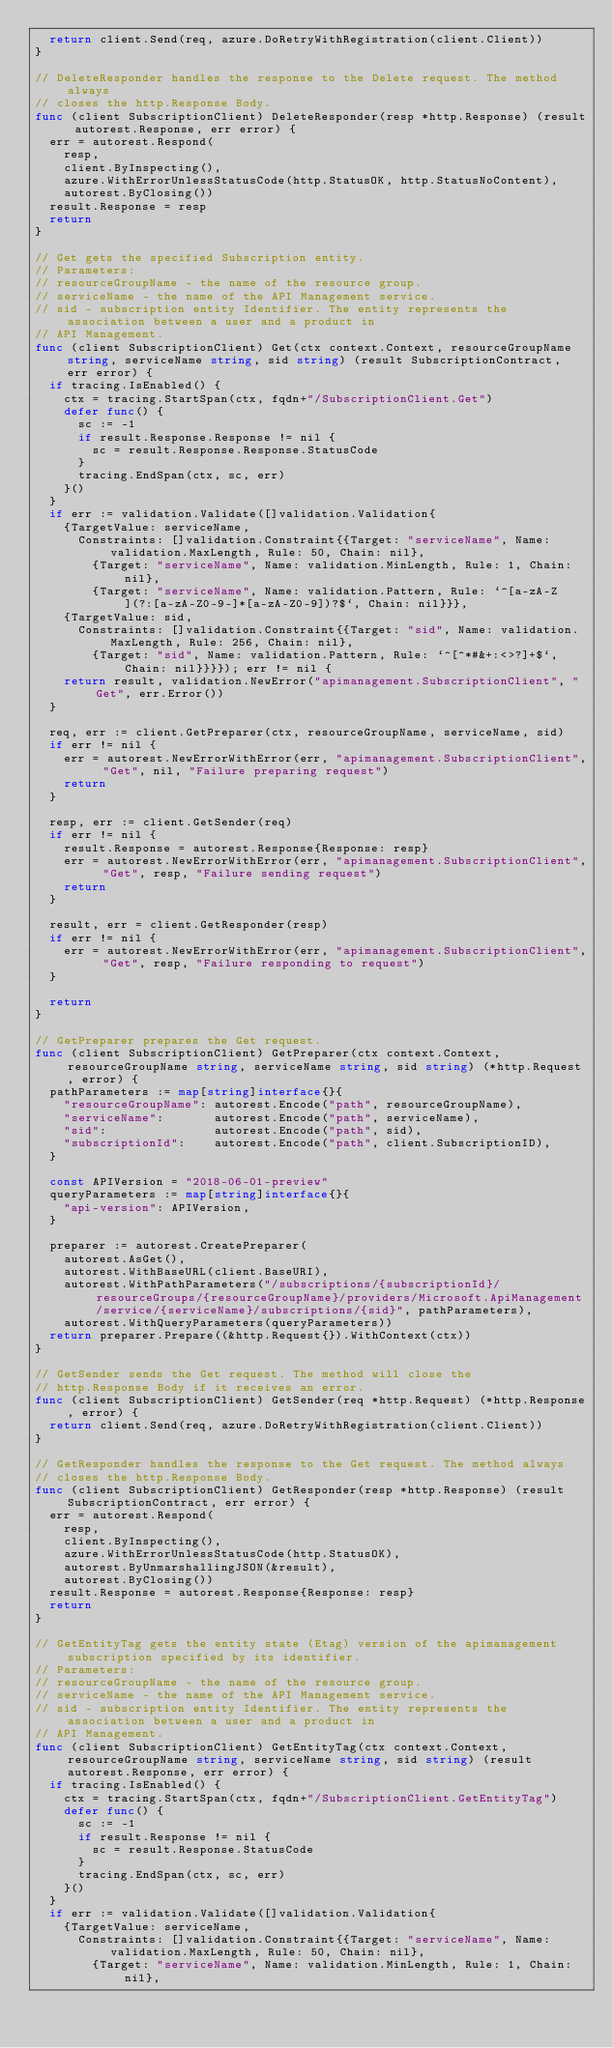<code> <loc_0><loc_0><loc_500><loc_500><_Go_>	return client.Send(req, azure.DoRetryWithRegistration(client.Client))
}

// DeleteResponder handles the response to the Delete request. The method always
// closes the http.Response Body.
func (client SubscriptionClient) DeleteResponder(resp *http.Response) (result autorest.Response, err error) {
	err = autorest.Respond(
		resp,
		client.ByInspecting(),
		azure.WithErrorUnlessStatusCode(http.StatusOK, http.StatusNoContent),
		autorest.ByClosing())
	result.Response = resp
	return
}

// Get gets the specified Subscription entity.
// Parameters:
// resourceGroupName - the name of the resource group.
// serviceName - the name of the API Management service.
// sid - subscription entity Identifier. The entity represents the association between a user and a product in
// API Management.
func (client SubscriptionClient) Get(ctx context.Context, resourceGroupName string, serviceName string, sid string) (result SubscriptionContract, err error) {
	if tracing.IsEnabled() {
		ctx = tracing.StartSpan(ctx, fqdn+"/SubscriptionClient.Get")
		defer func() {
			sc := -1
			if result.Response.Response != nil {
				sc = result.Response.Response.StatusCode
			}
			tracing.EndSpan(ctx, sc, err)
		}()
	}
	if err := validation.Validate([]validation.Validation{
		{TargetValue: serviceName,
			Constraints: []validation.Constraint{{Target: "serviceName", Name: validation.MaxLength, Rule: 50, Chain: nil},
				{Target: "serviceName", Name: validation.MinLength, Rule: 1, Chain: nil},
				{Target: "serviceName", Name: validation.Pattern, Rule: `^[a-zA-Z](?:[a-zA-Z0-9-]*[a-zA-Z0-9])?$`, Chain: nil}}},
		{TargetValue: sid,
			Constraints: []validation.Constraint{{Target: "sid", Name: validation.MaxLength, Rule: 256, Chain: nil},
				{Target: "sid", Name: validation.Pattern, Rule: `^[^*#&+:<>?]+$`, Chain: nil}}}}); err != nil {
		return result, validation.NewError("apimanagement.SubscriptionClient", "Get", err.Error())
	}

	req, err := client.GetPreparer(ctx, resourceGroupName, serviceName, sid)
	if err != nil {
		err = autorest.NewErrorWithError(err, "apimanagement.SubscriptionClient", "Get", nil, "Failure preparing request")
		return
	}

	resp, err := client.GetSender(req)
	if err != nil {
		result.Response = autorest.Response{Response: resp}
		err = autorest.NewErrorWithError(err, "apimanagement.SubscriptionClient", "Get", resp, "Failure sending request")
		return
	}

	result, err = client.GetResponder(resp)
	if err != nil {
		err = autorest.NewErrorWithError(err, "apimanagement.SubscriptionClient", "Get", resp, "Failure responding to request")
	}

	return
}

// GetPreparer prepares the Get request.
func (client SubscriptionClient) GetPreparer(ctx context.Context, resourceGroupName string, serviceName string, sid string) (*http.Request, error) {
	pathParameters := map[string]interface{}{
		"resourceGroupName": autorest.Encode("path", resourceGroupName),
		"serviceName":       autorest.Encode("path", serviceName),
		"sid":               autorest.Encode("path", sid),
		"subscriptionId":    autorest.Encode("path", client.SubscriptionID),
	}

	const APIVersion = "2018-06-01-preview"
	queryParameters := map[string]interface{}{
		"api-version": APIVersion,
	}

	preparer := autorest.CreatePreparer(
		autorest.AsGet(),
		autorest.WithBaseURL(client.BaseURI),
		autorest.WithPathParameters("/subscriptions/{subscriptionId}/resourceGroups/{resourceGroupName}/providers/Microsoft.ApiManagement/service/{serviceName}/subscriptions/{sid}", pathParameters),
		autorest.WithQueryParameters(queryParameters))
	return preparer.Prepare((&http.Request{}).WithContext(ctx))
}

// GetSender sends the Get request. The method will close the
// http.Response Body if it receives an error.
func (client SubscriptionClient) GetSender(req *http.Request) (*http.Response, error) {
	return client.Send(req, azure.DoRetryWithRegistration(client.Client))
}

// GetResponder handles the response to the Get request. The method always
// closes the http.Response Body.
func (client SubscriptionClient) GetResponder(resp *http.Response) (result SubscriptionContract, err error) {
	err = autorest.Respond(
		resp,
		client.ByInspecting(),
		azure.WithErrorUnlessStatusCode(http.StatusOK),
		autorest.ByUnmarshallingJSON(&result),
		autorest.ByClosing())
	result.Response = autorest.Response{Response: resp}
	return
}

// GetEntityTag gets the entity state (Etag) version of the apimanagement subscription specified by its identifier.
// Parameters:
// resourceGroupName - the name of the resource group.
// serviceName - the name of the API Management service.
// sid - subscription entity Identifier. The entity represents the association between a user and a product in
// API Management.
func (client SubscriptionClient) GetEntityTag(ctx context.Context, resourceGroupName string, serviceName string, sid string) (result autorest.Response, err error) {
	if tracing.IsEnabled() {
		ctx = tracing.StartSpan(ctx, fqdn+"/SubscriptionClient.GetEntityTag")
		defer func() {
			sc := -1
			if result.Response != nil {
				sc = result.Response.StatusCode
			}
			tracing.EndSpan(ctx, sc, err)
		}()
	}
	if err := validation.Validate([]validation.Validation{
		{TargetValue: serviceName,
			Constraints: []validation.Constraint{{Target: "serviceName", Name: validation.MaxLength, Rule: 50, Chain: nil},
				{Target: "serviceName", Name: validation.MinLength, Rule: 1, Chain: nil},</code> 